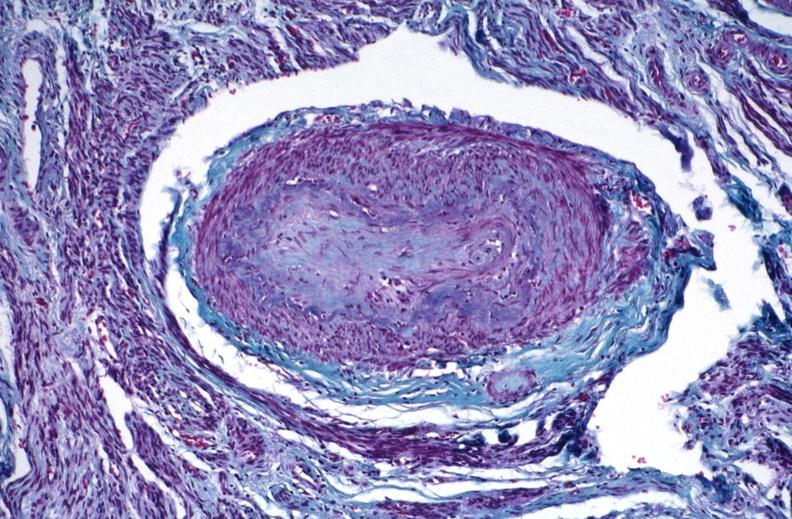what stain?
Answer the question using a single word or phrase. Thrichrome 